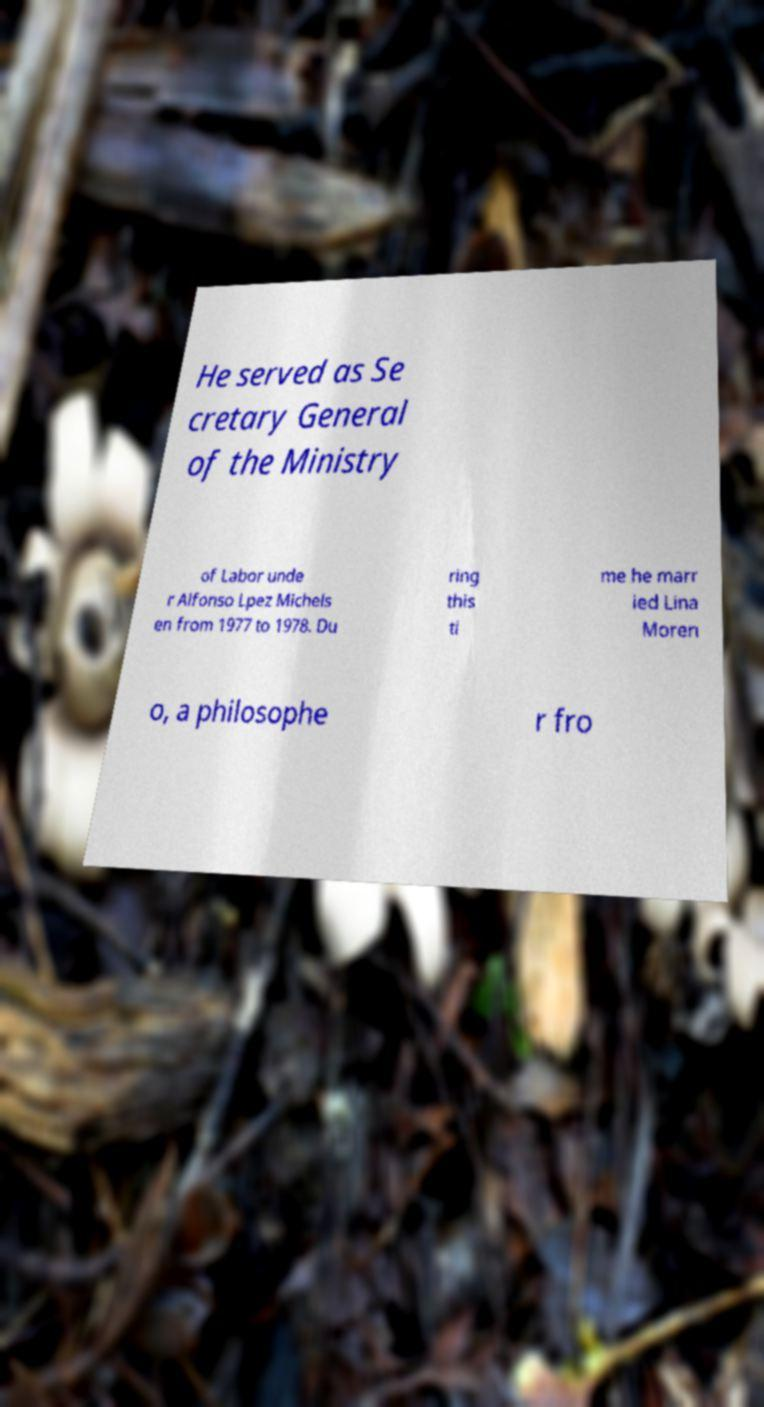Please identify and transcribe the text found in this image. He served as Se cretary General of the Ministry of Labor unde r Alfonso Lpez Michels en from 1977 to 1978. Du ring this ti me he marr ied Lina Moren o, a philosophe r fro 